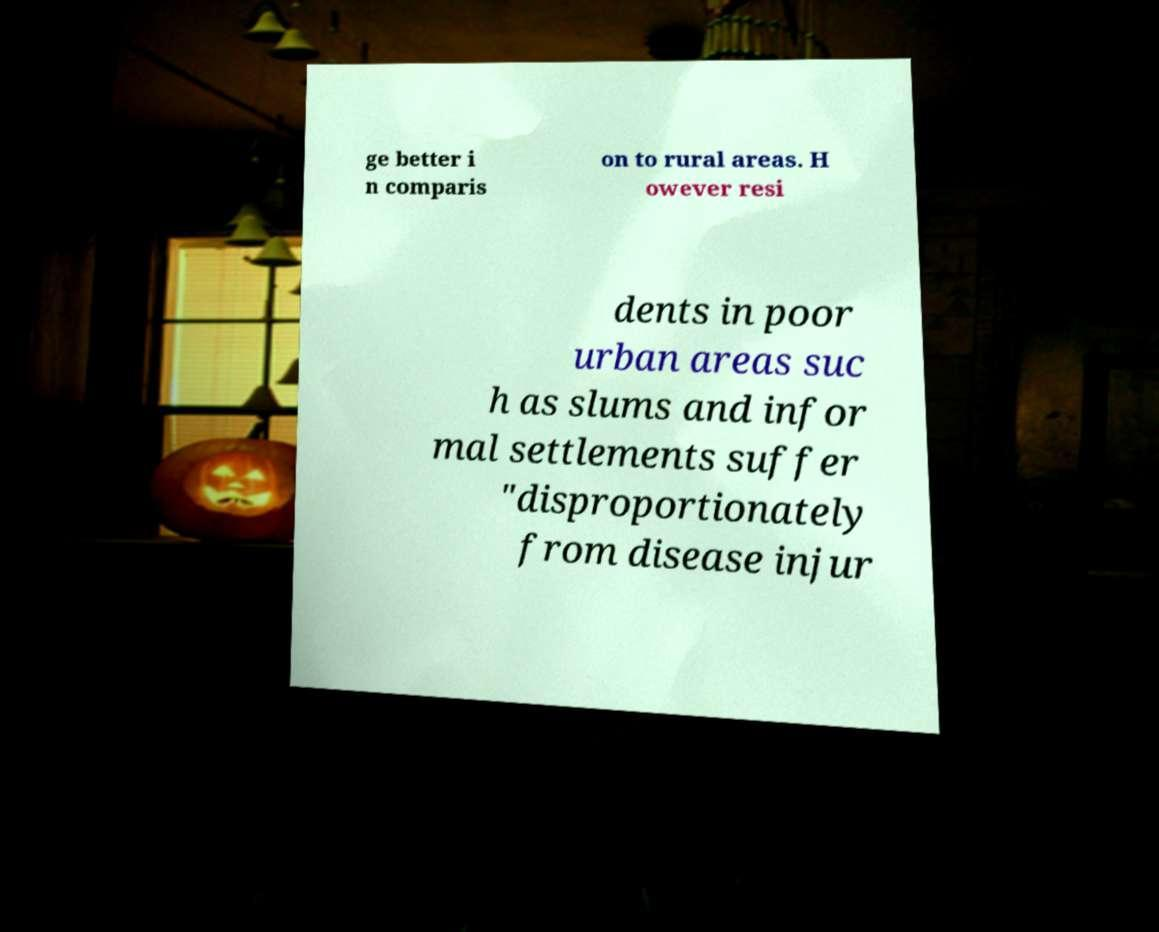What messages or text are displayed in this image? I need them in a readable, typed format. ge better i n comparis on to rural areas. H owever resi dents in poor urban areas suc h as slums and infor mal settlements suffer "disproportionately from disease injur 